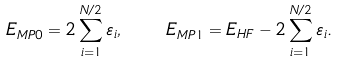Convert formula to latex. <formula><loc_0><loc_0><loc_500><loc_500>E _ { M P 0 } = 2 \sum _ { i = 1 } ^ { N / 2 } \varepsilon _ { i } , \quad E _ { M P 1 } = E _ { H F } - 2 \sum _ { i = 1 } ^ { N / 2 } \varepsilon _ { i } .</formula> 